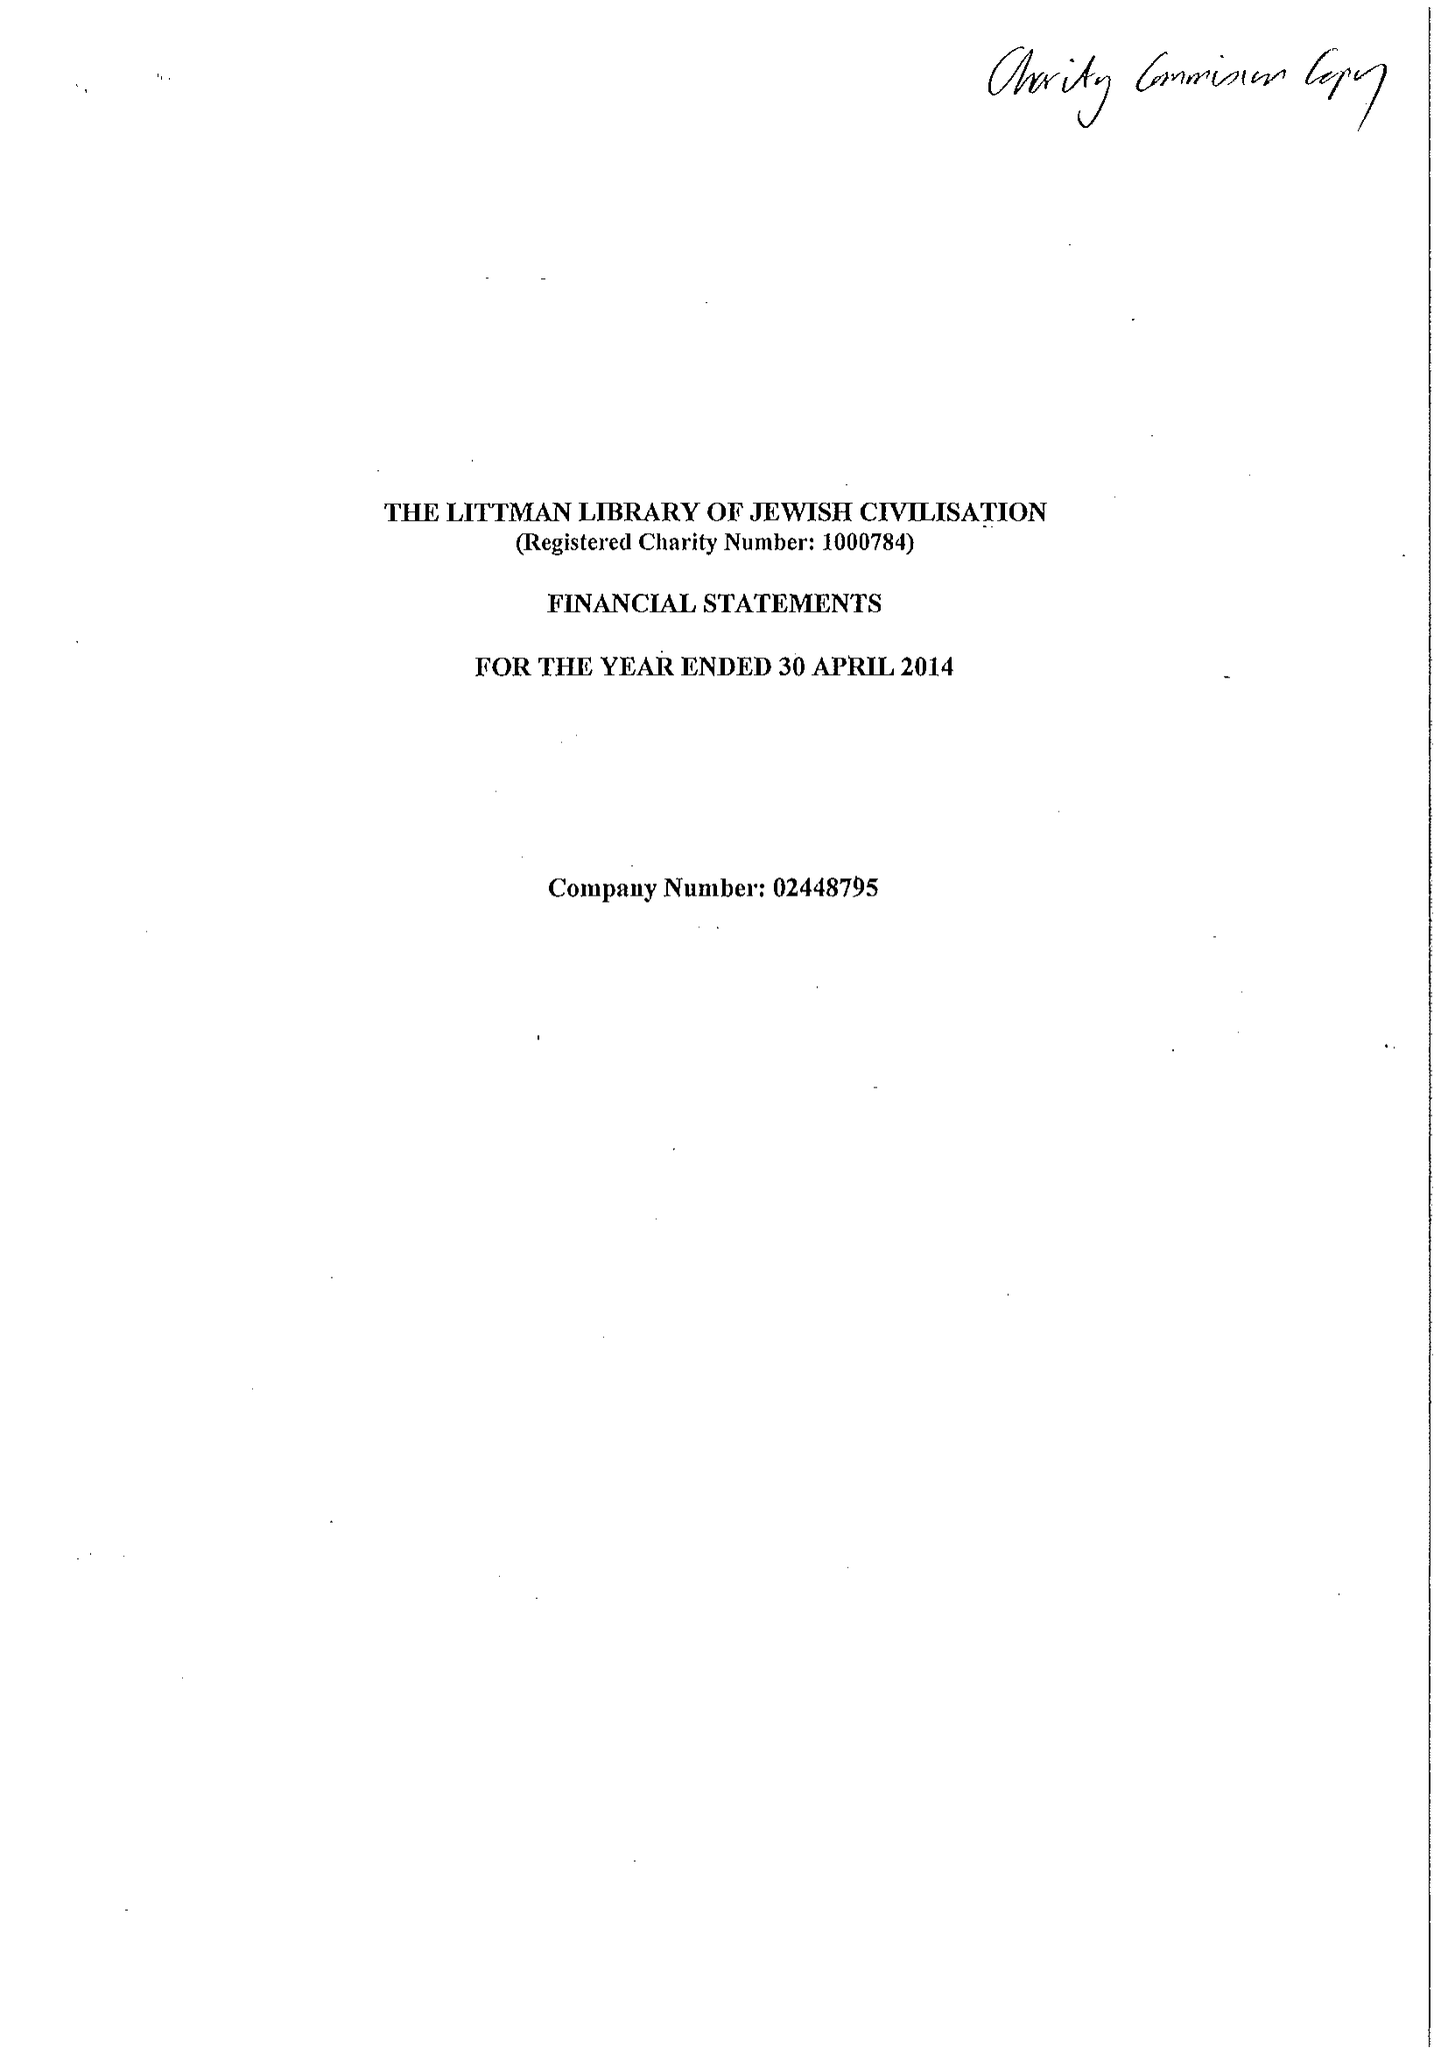What is the value for the address__post_town?
Answer the question using a single word or phrase. SOMERTON 